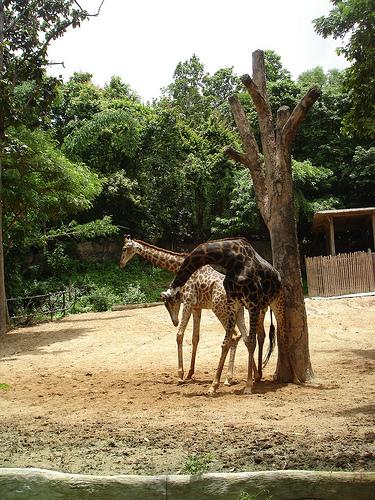What continent are these animals from?
Quick response, please. Africa. Are the animals fighting?
Quick response, please. No. Are these animals in a zoo?
Short answer required. Yes. 